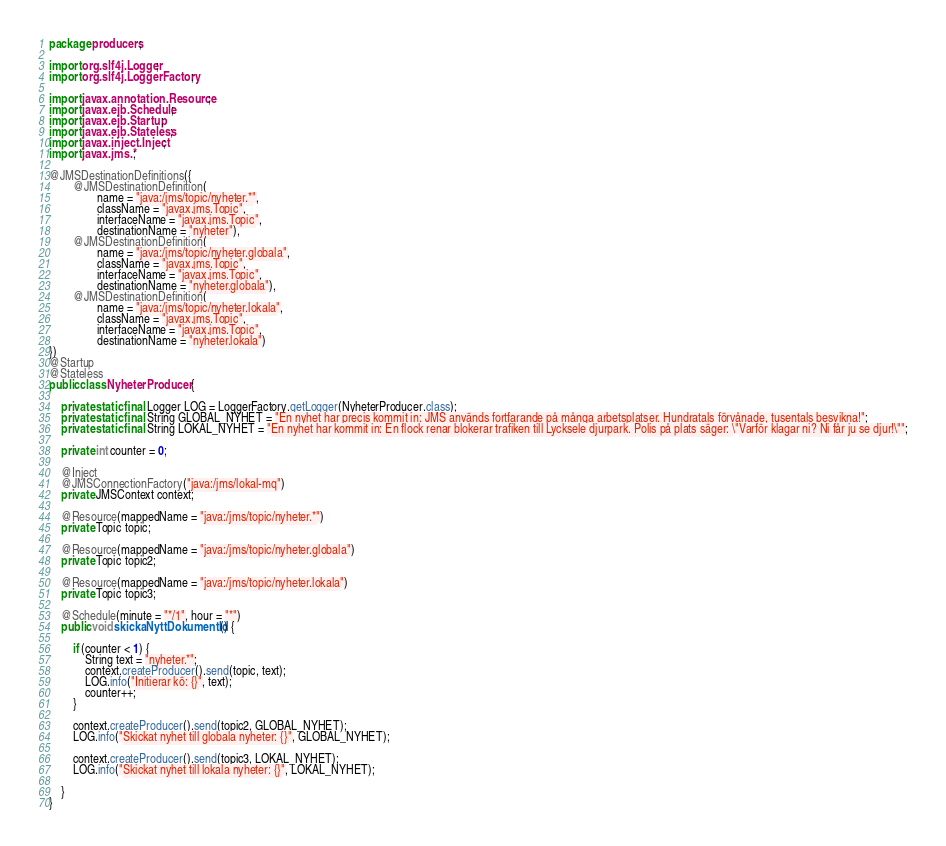Convert code to text. <code><loc_0><loc_0><loc_500><loc_500><_Java_>package producers;

import org.slf4j.Logger;
import org.slf4j.LoggerFactory;

import javax.annotation.Resource;
import javax.ejb.Schedule;
import javax.ejb.Startup;
import javax.ejb.Stateless;
import javax.inject.Inject;
import javax.jms.*;

@JMSDestinationDefinitions({
        @JMSDestinationDefinition(
                name = "java:/jms/topic/nyheter.*",
                className = "javax.jms.Topic",
                interfaceName = "javax.jms.Topic",
                destinationName = "nyheter"),
        @JMSDestinationDefinition(
                name = "java:/jms/topic/nyheter.globala",
                className = "javax.jms.Topic",
                interfaceName = "javax.jms.Topic",
                destinationName = "nyheter.globala"),
        @JMSDestinationDefinition(
                name = "java:/jms/topic/nyheter.lokala",
                className = "javax.jms.Topic",
                interfaceName = "javax.jms.Topic",
                destinationName = "nyheter.lokala")
})
@Startup
@Stateless
public class NyheterProducer {

    private static final Logger LOG = LoggerFactory.getLogger(NyheterProducer.class);
    private static final String GLOBAL_NYHET = "En nyhet har precis kommit in: JMS används fortfarande på många arbetsplatser. Hundratals förvånade, tusentals besvikna!";
    private static final String LOKAL_NYHET = "En nyhet har kommit in: En flock renar blokerar trafiken till Lycksele djurpark. Polis på plats säger: \"Varför klagar ni? Ni får ju se djur!\"";

    private int counter = 0;

    @Inject
    @JMSConnectionFactory("java:/jms/lokal-mq")
    private JMSContext context;

    @Resource(mappedName = "java:/jms/topic/nyheter.*")
    private Topic topic;

    @Resource(mappedName = "java:/jms/topic/nyheter.globala")
    private Topic topic2;

    @Resource(mappedName = "java:/jms/topic/nyheter.lokala")
    private Topic topic3;

    @Schedule(minute = "*/1", hour = "*")
    public void skickaNyttDokumentId() {

        if (counter < 1) {
            String text = "nyheter.*";
            context.createProducer().send(topic, text);
            LOG.info("Initierar kö: {}", text);
            counter++;
        }

        context.createProducer().send(topic2, GLOBAL_NYHET);
        LOG.info("Skickat nyhet till globala nyheter: {}", GLOBAL_NYHET);

        context.createProducer().send(topic3, LOKAL_NYHET);
        LOG.info("Skickat nyhet till lokala nyheter: {}", LOKAL_NYHET);

    }
}
</code> 